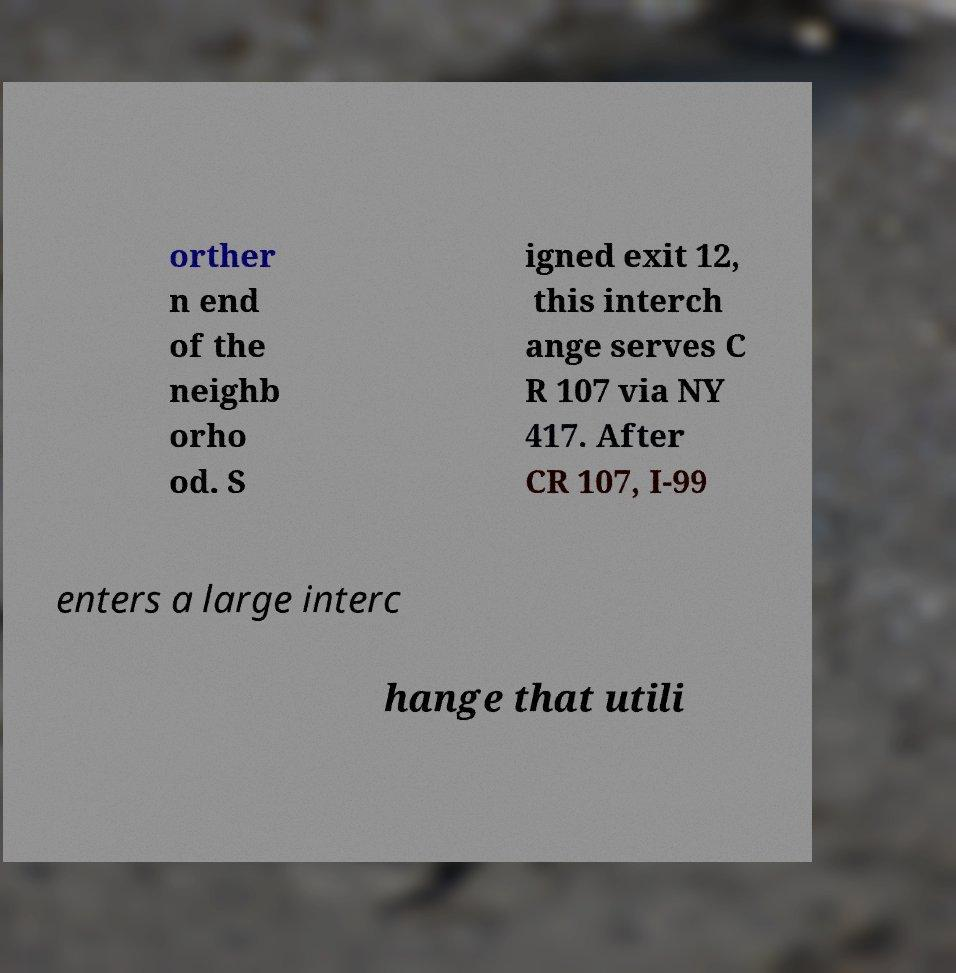Can you accurately transcribe the text from the provided image for me? orther n end of the neighb orho od. S igned exit 12, this interch ange serves C R 107 via NY 417. After CR 107, I-99 enters a large interc hange that utili 